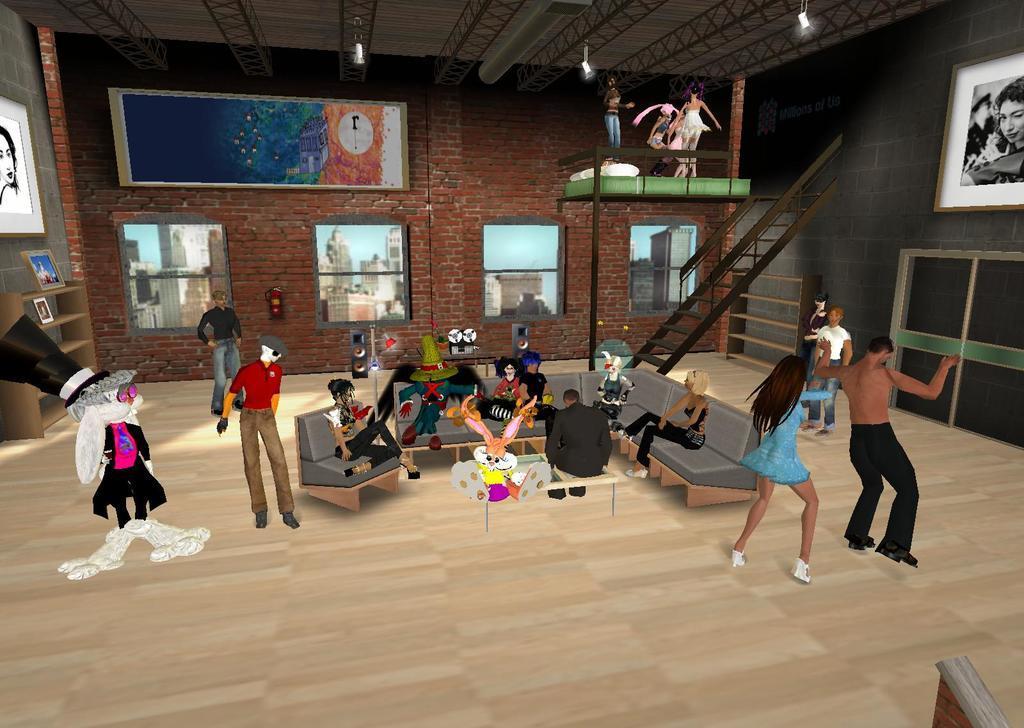In one or two sentences, can you explain what this image depicts? In this picture I can see an animated image, on which few people are inside of the house. 